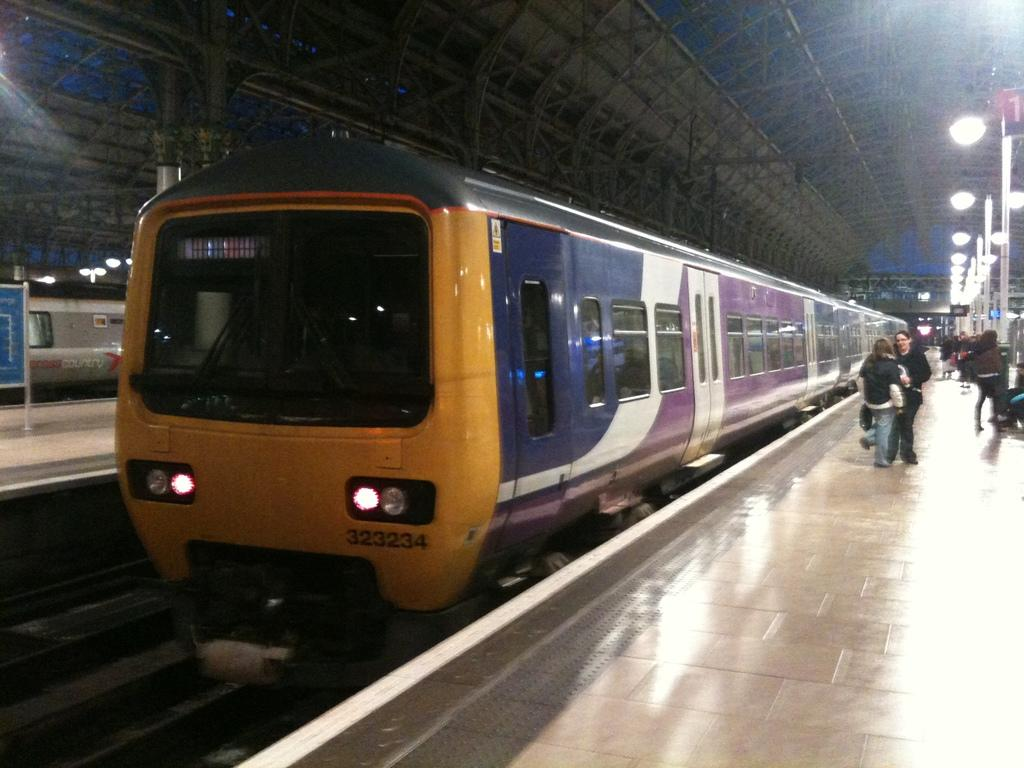What is the main subject of the image? The main subject of the image is a train. What can be seen on the right side of the image? There is a railway platform on the right side of the image. What is happening on the platform? There are people standing on the platform. What is visible at the top of the image? There are lights visible at the top of the image. What type of meat is being served to the achiever in the image? There is no achiever or meat present in the image; it features a train and a railway platform with people standing on it. 